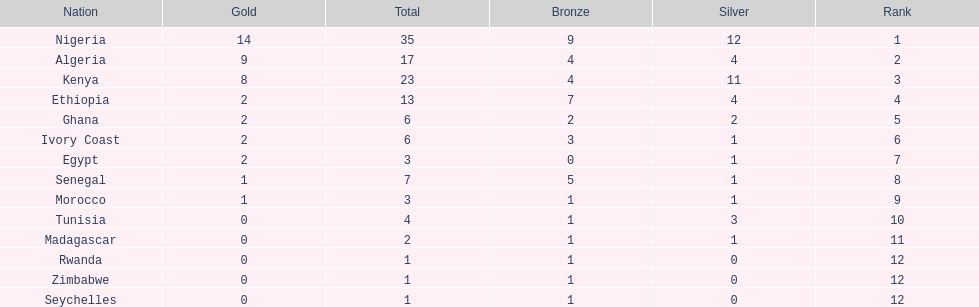How many medals did senegal win? 7. 